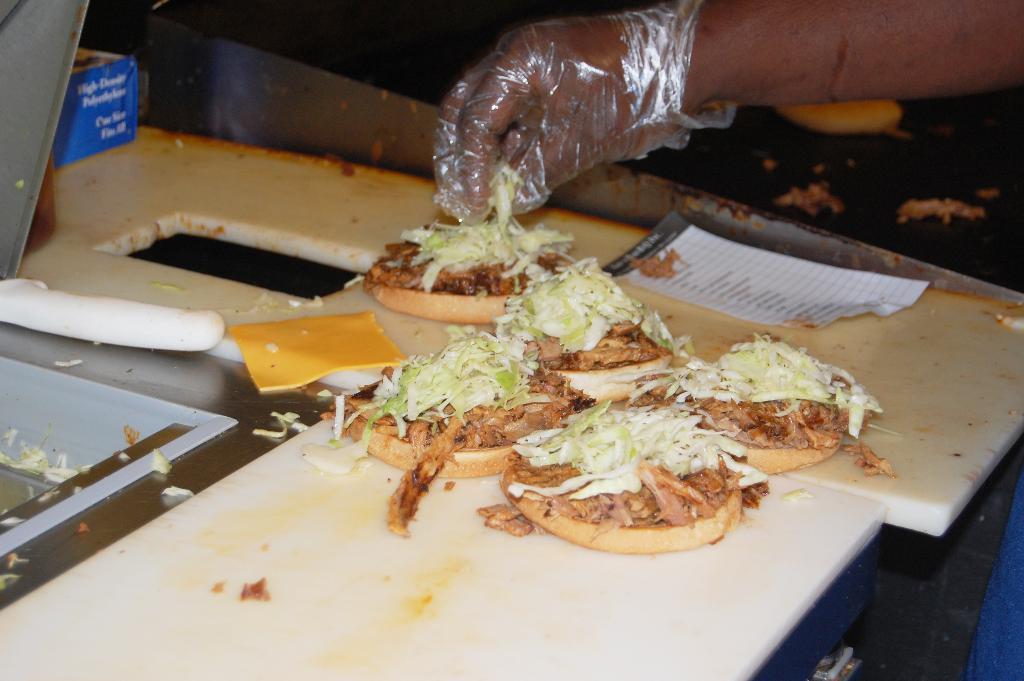In one or two sentences, can you explain what this image depicts? In the center of the image we can see pizzas placed on the table and persons hand. In the background we can see pizza on table. 